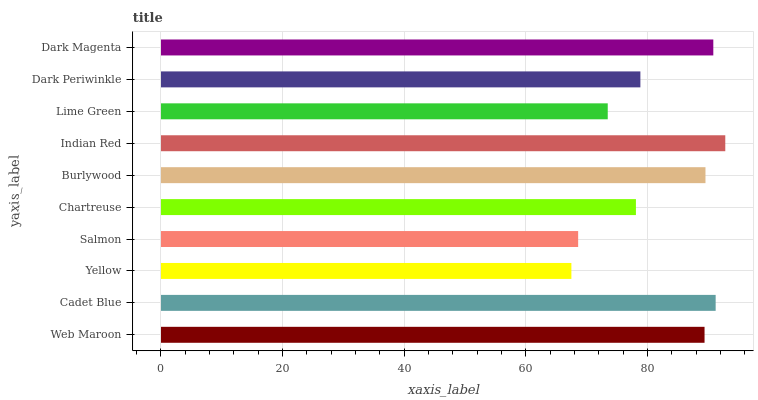Is Yellow the minimum?
Answer yes or no. Yes. Is Indian Red the maximum?
Answer yes or no. Yes. Is Cadet Blue the minimum?
Answer yes or no. No. Is Cadet Blue the maximum?
Answer yes or no. No. Is Cadet Blue greater than Web Maroon?
Answer yes or no. Yes. Is Web Maroon less than Cadet Blue?
Answer yes or no. Yes. Is Web Maroon greater than Cadet Blue?
Answer yes or no. No. Is Cadet Blue less than Web Maroon?
Answer yes or no. No. Is Web Maroon the high median?
Answer yes or no. Yes. Is Dark Periwinkle the low median?
Answer yes or no. Yes. Is Burlywood the high median?
Answer yes or no. No. Is Yellow the low median?
Answer yes or no. No. 